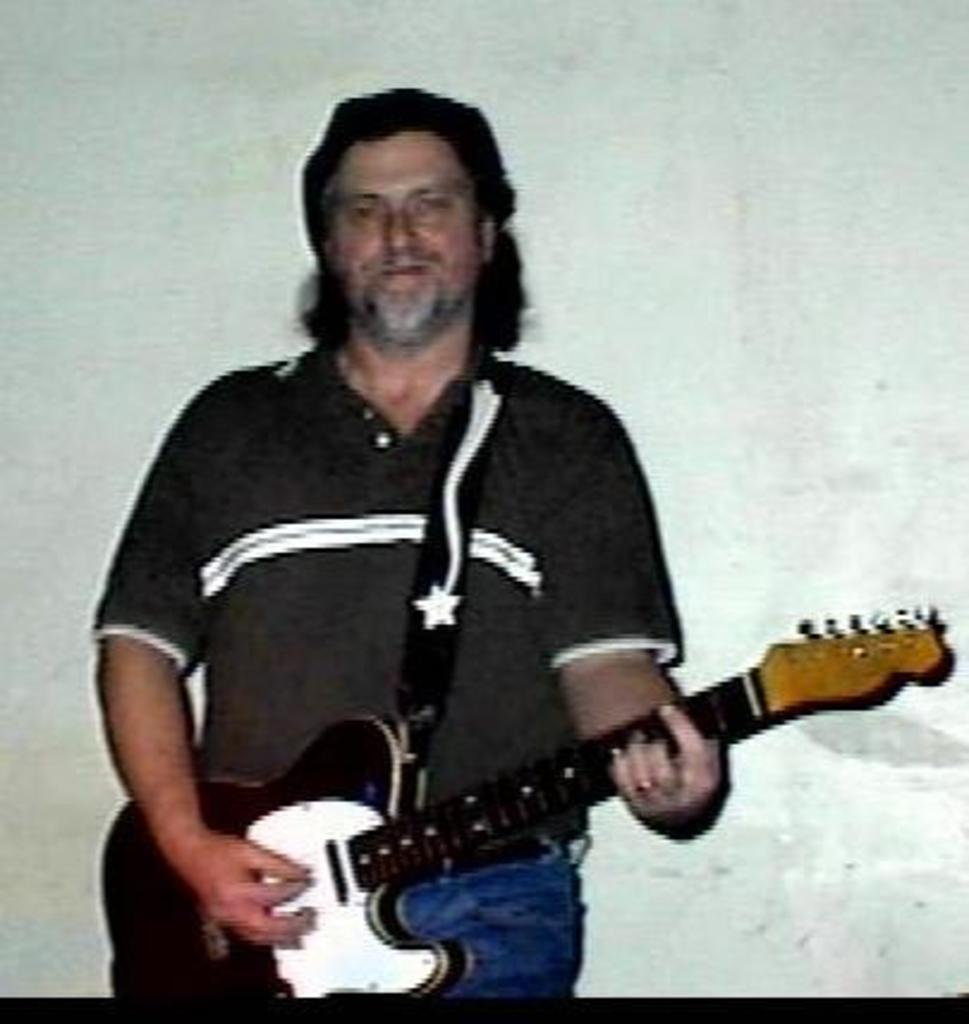Where is the scene of the image taking place? The image is in a room. What is the man in the image doing? The man is playing a guitar. What is the man wearing in the image? The man is wearing a black t-shirt. What is the color of the background in the room? The background of the room is white in color. What type of creature can be seen interacting with the man in the image? There is no creature present in the image; it only features a man playing a guitar in a room with a white background. 